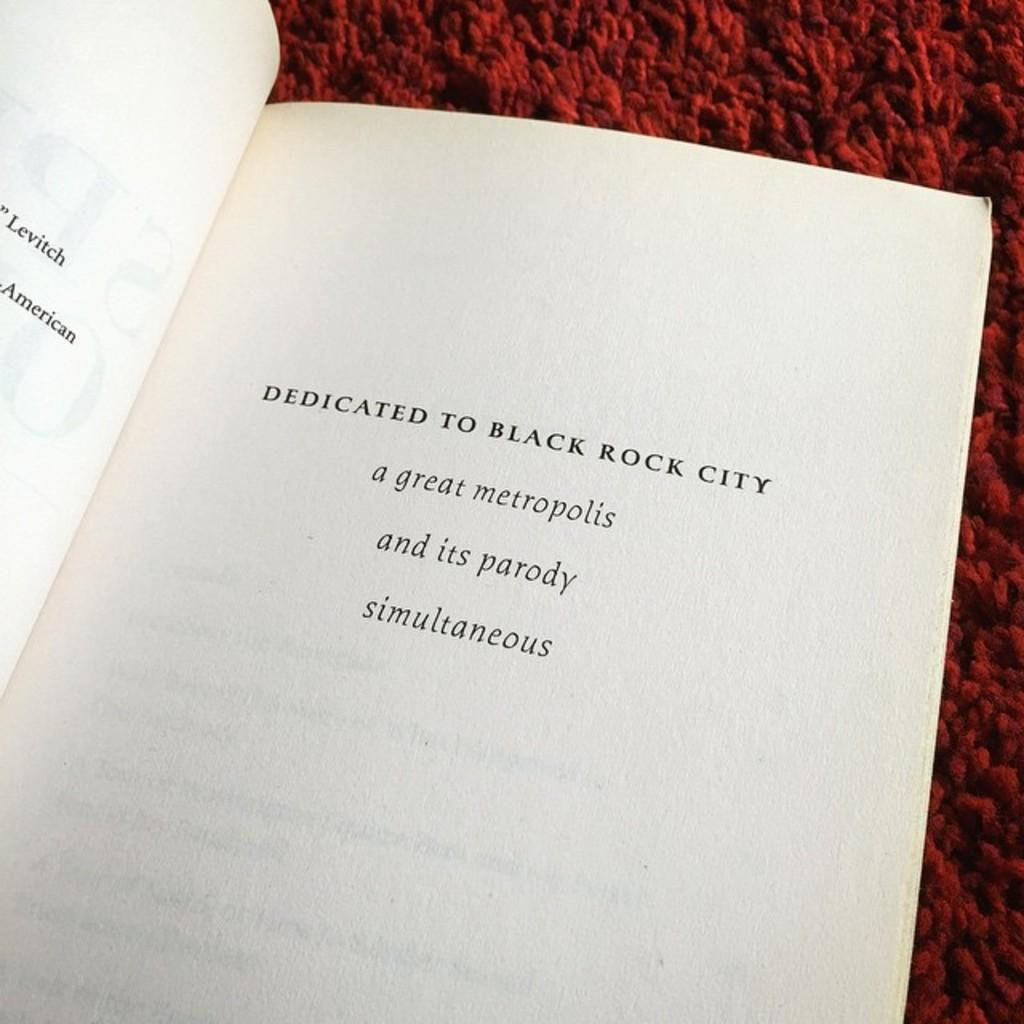What is this book dedicated?
Provide a succinct answer. Black rock city. 